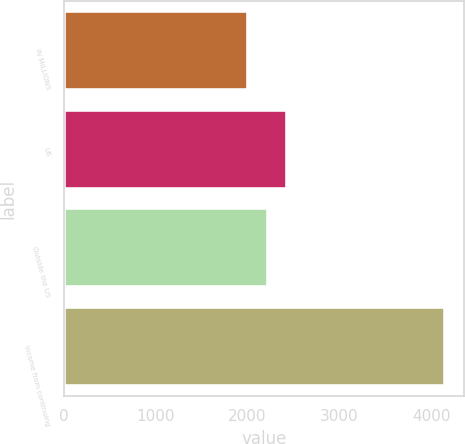Convert chart. <chart><loc_0><loc_0><loc_500><loc_500><bar_chart><fcel>IN MILLIONS<fcel>US<fcel>Outside the US<fcel>Income from continuing<nl><fcel>2006<fcel>2435.68<fcel>2220.84<fcel>4154.4<nl></chart> 